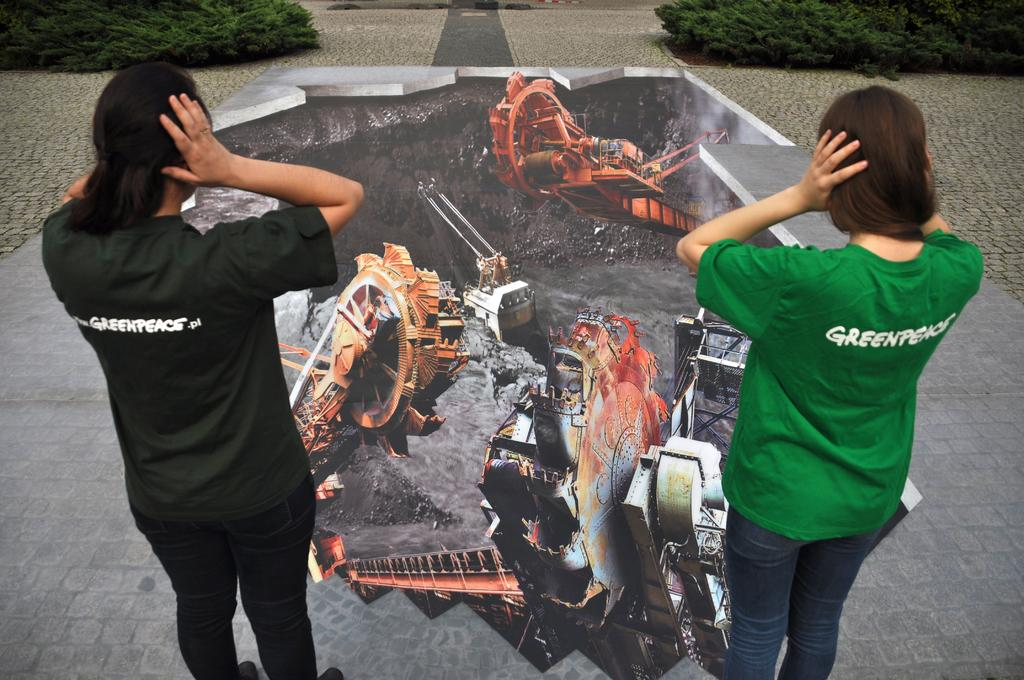<image>
Write a terse but informative summary of the picture. Two women look at a chalk drawing with GREENPEACE on their shirts. 